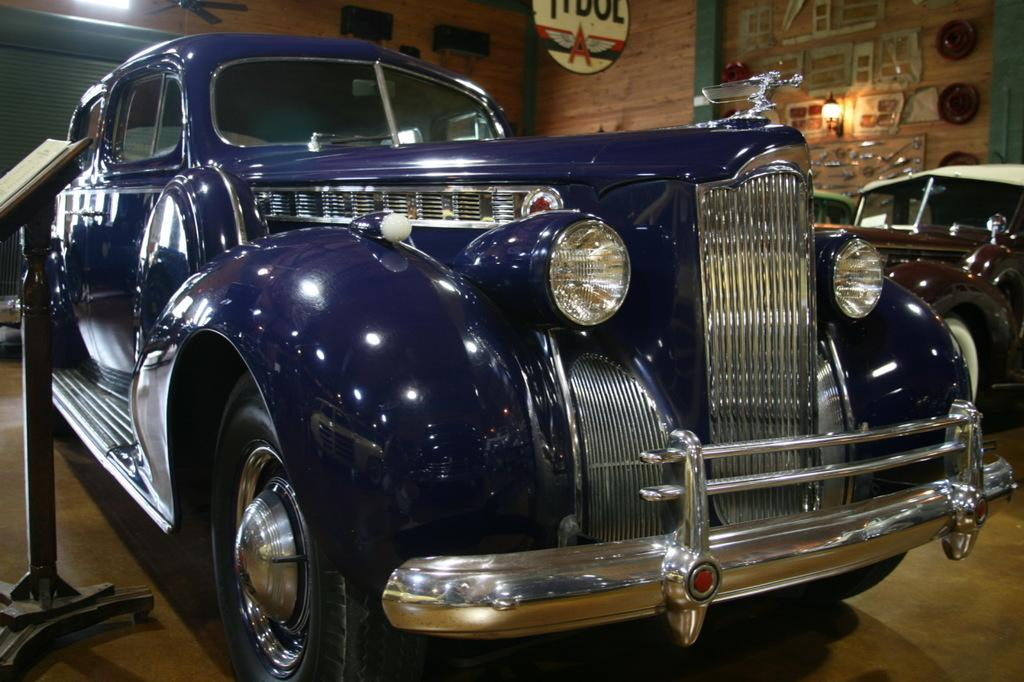What type of vehicles are in the image? There are cars in the image. What can be seen in the background of the image? There is a wooden wall in the background of the image. What is attached to the wooden wall? There are tools on the wooden wall. Can you see a duck swimming in the image? There is no duck present in the image. 